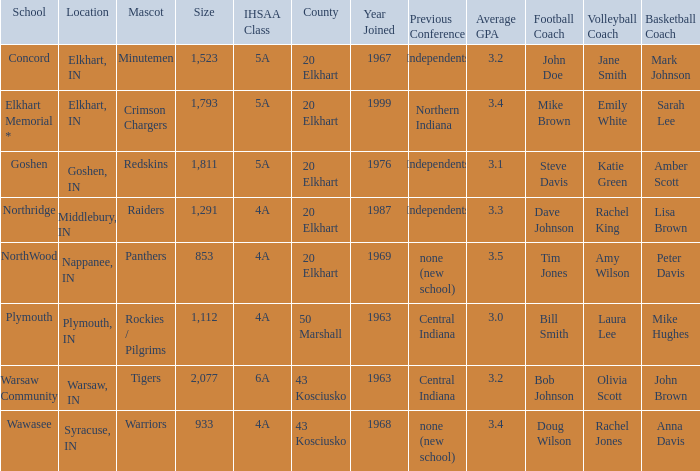What country joined before 1976, with IHSSA class of 5a, and a size larger than 1,112? 20 Elkhart. 